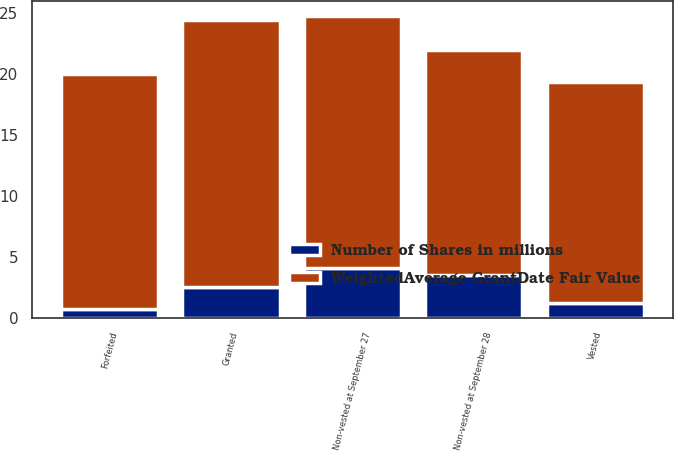Convert chart to OTSL. <chart><loc_0><loc_0><loc_500><loc_500><stacked_bar_chart><ecel><fcel>Non-vested at September 28<fcel>Granted<fcel>Vested<fcel>Forfeited<fcel>Non-vested at September 27<nl><fcel>Number of Shares in millions<fcel>3.5<fcel>2.5<fcel>1.2<fcel>0.7<fcel>4.1<nl><fcel>WeightedAverage GrantDate Fair Value<fcel>18.51<fcel>22<fcel>18.13<fcel>19.29<fcel>20.67<nl></chart> 